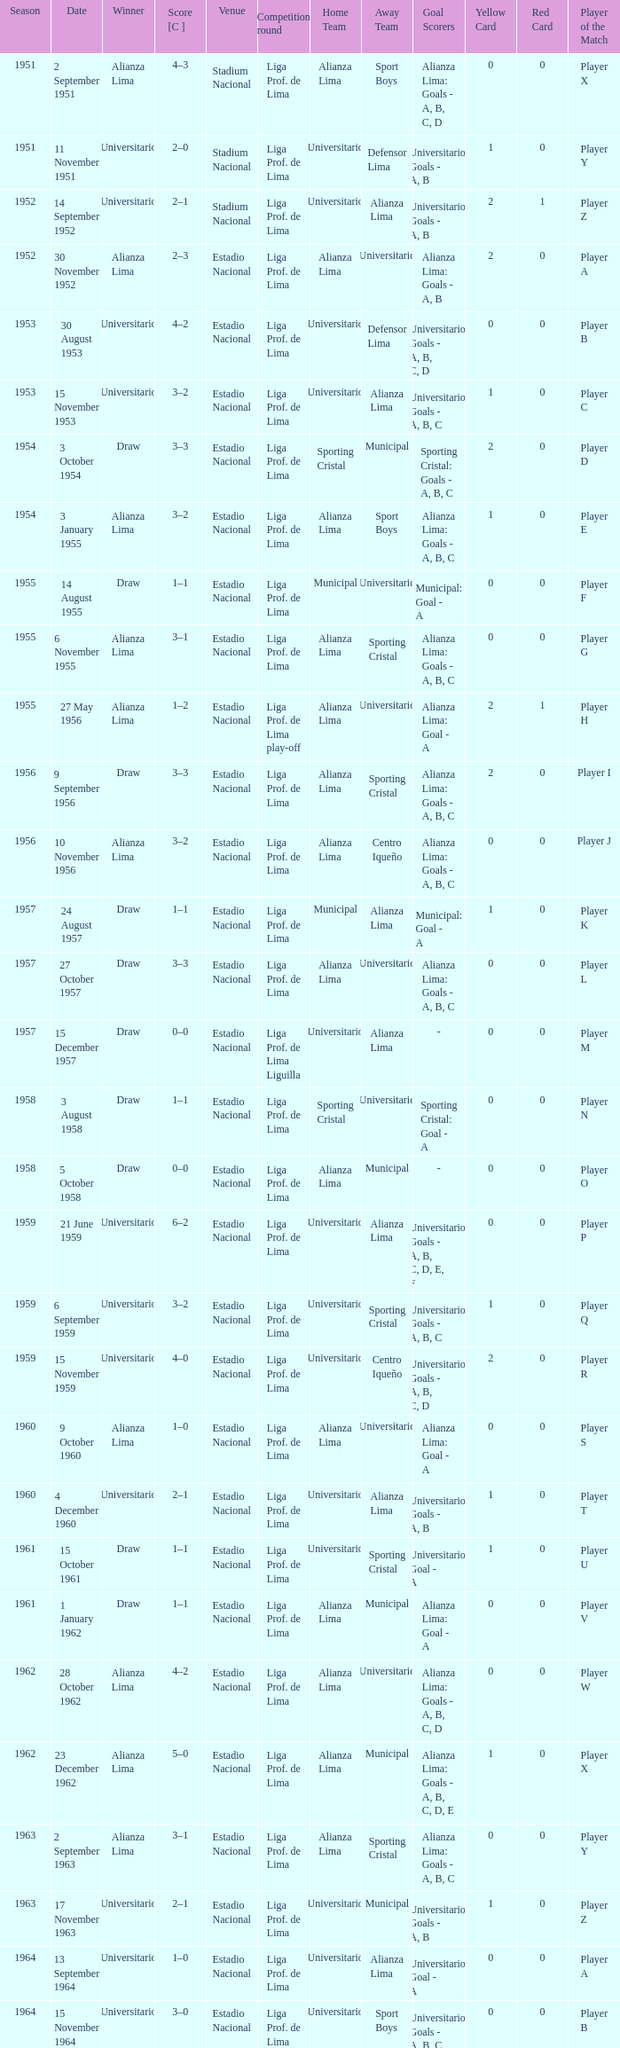Who was the winner on 15 December 1957? Draw. 